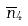Convert formula to latex. <formula><loc_0><loc_0><loc_500><loc_500>\overline { n } _ { 4 }</formula> 